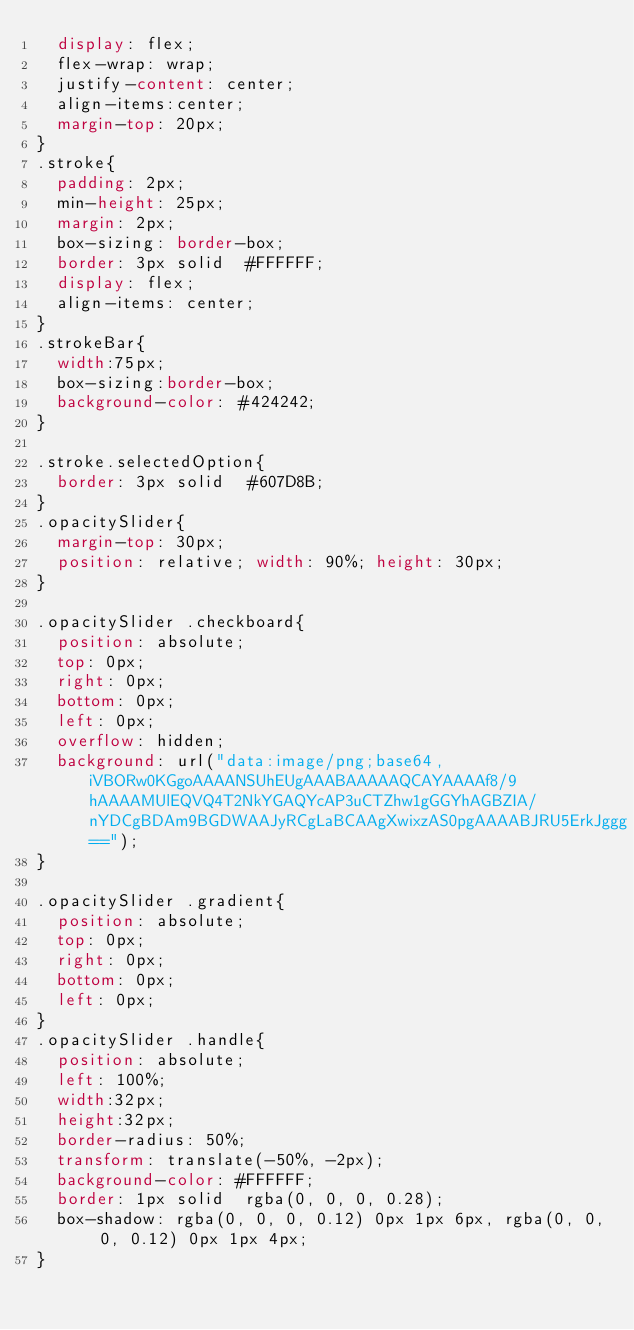Convert code to text. <code><loc_0><loc_0><loc_500><loc_500><_CSS_>  display: flex;
  flex-wrap: wrap;
  justify-content: center;
  align-items:center;
  margin-top: 20px;
}
.stroke{
  padding: 2px;
  min-height: 25px;
  margin: 2px;
  box-sizing: border-box;
  border: 3px solid  #FFFFFF;
  display: flex;
  align-items: center;
}
.strokeBar{
  width:75px;
  box-sizing:border-box;
  background-color: #424242;
}

.stroke.selectedOption{
  border: 3px solid  #607D8B;
}
.opacitySlider{
  margin-top: 30px;
  position: relative; width: 90%; height: 30px;
}

.opacitySlider .checkboard{
  position: absolute;
  top: 0px;
  right: 0px;
  bottom: 0px;
  left: 0px;
  overflow: hidden;
  background: url("data:image/png;base64,iVBORw0KGgoAAAANSUhEUgAAABAAAAAQCAYAAAAf8/9hAAAAMUlEQVQ4T2NkYGAQYcAP3uCTZhw1gGGYhAGBZIA/nYDCgBDAm9BGDWAAJyRCgLaBCAAgXwixzAS0pgAAAABJRU5ErkJggg==");
}

.opacitySlider .gradient{
  position: absolute;
  top: 0px;
  right: 0px;
  bottom: 0px;
  left: 0px;
}
.opacitySlider .handle{
  position: absolute;
  left: 100%;
  width:32px;
  height:32px;
  border-radius: 50%;
  transform: translate(-50%, -2px);
  background-color: #FFFFFF;
  border: 1px solid  rgba(0, 0, 0, 0.28);
  box-shadow: rgba(0, 0, 0, 0.12) 0px 1px 6px, rgba(0, 0, 0, 0.12) 0px 1px 4px;
}</code> 